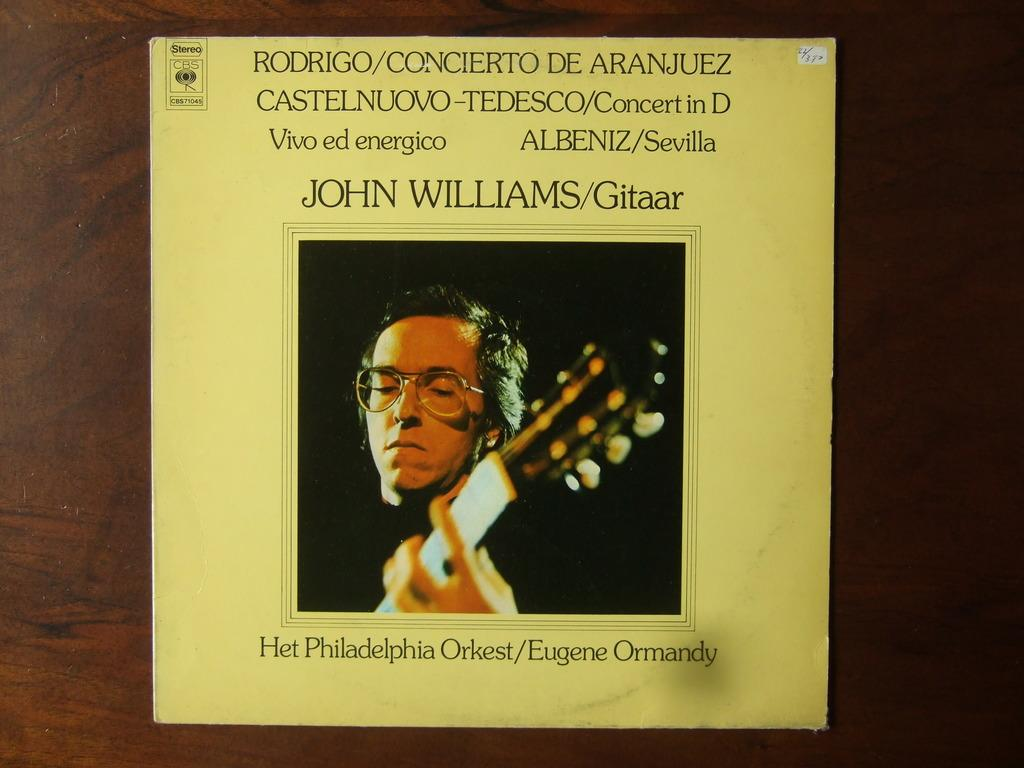<image>
Provide a brief description of the given image. Yellow album cover for John Williams showing a man playing a guitar. 